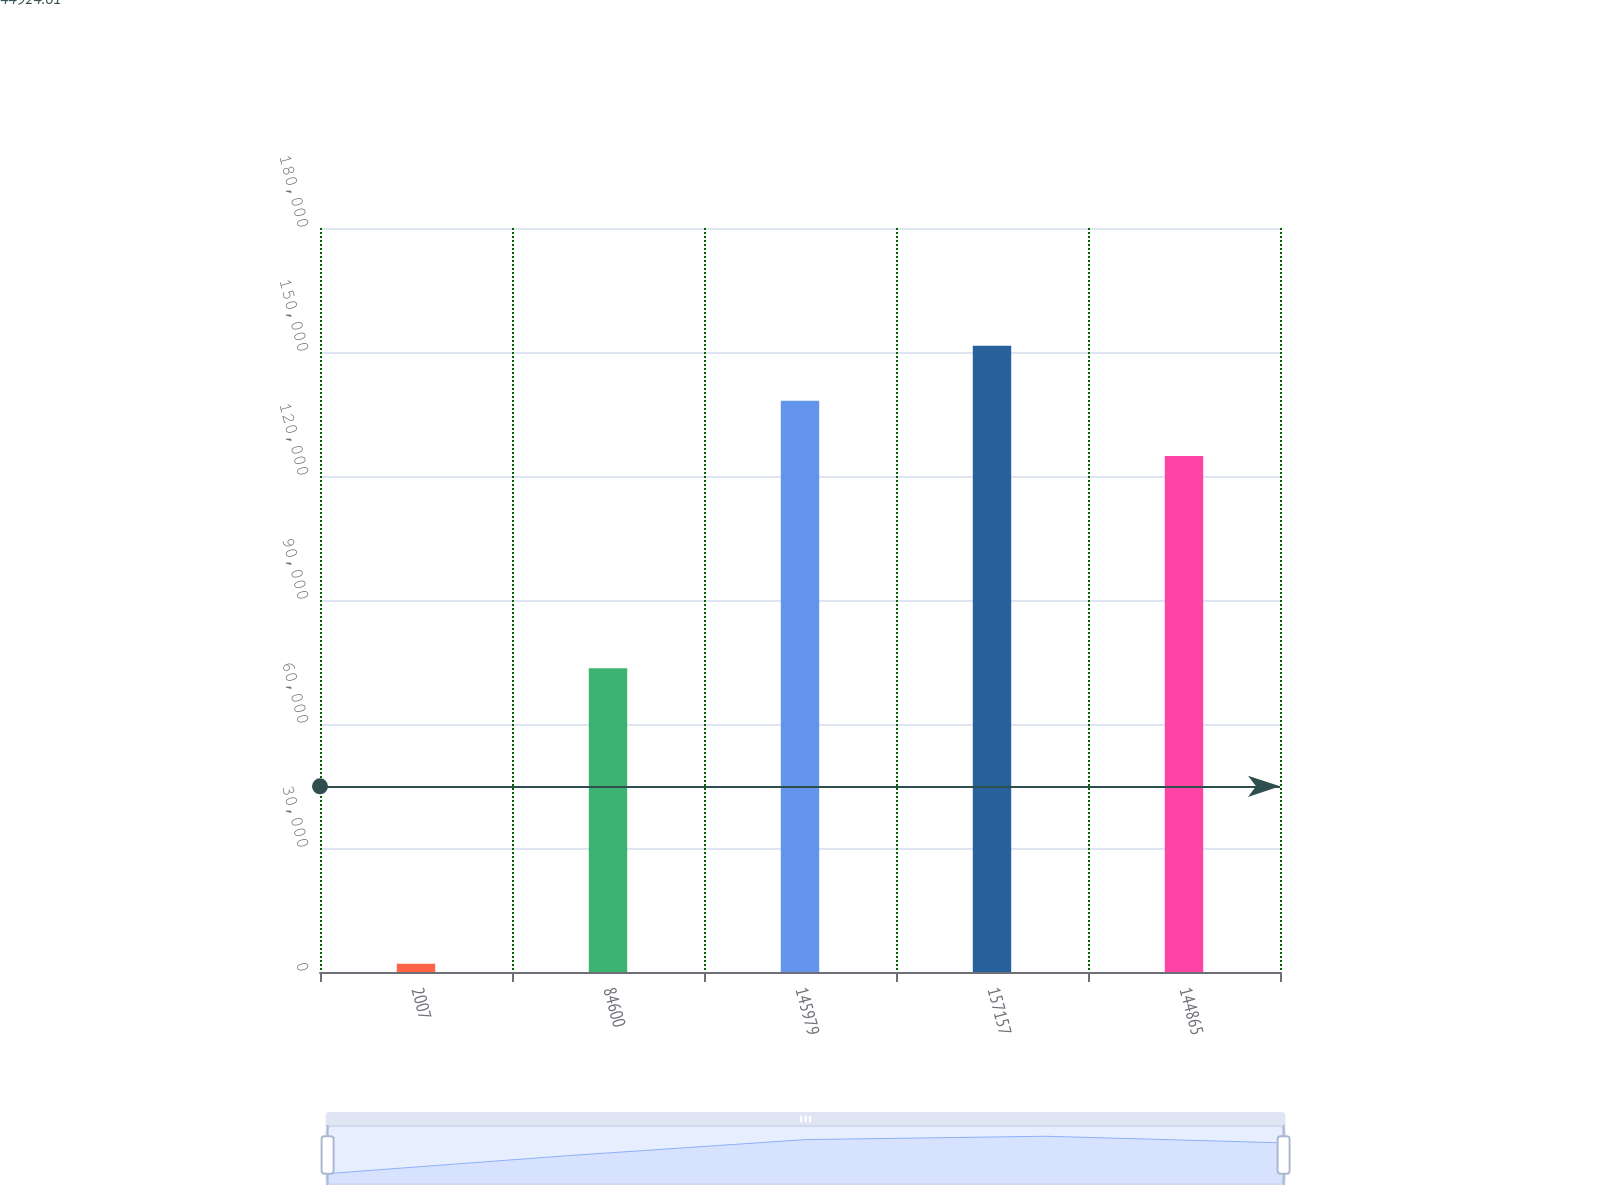Convert chart to OTSL. <chart><loc_0><loc_0><loc_500><loc_500><bar_chart><fcel>2007<fcel>84600<fcel>145979<fcel>157157<fcel>144865<nl><fcel>2007<fcel>73469<fcel>138198<fcel>151529<fcel>124867<nl></chart> 